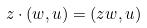<formula> <loc_0><loc_0><loc_500><loc_500>z \cdot ( w , u ) = ( z w , u )</formula> 